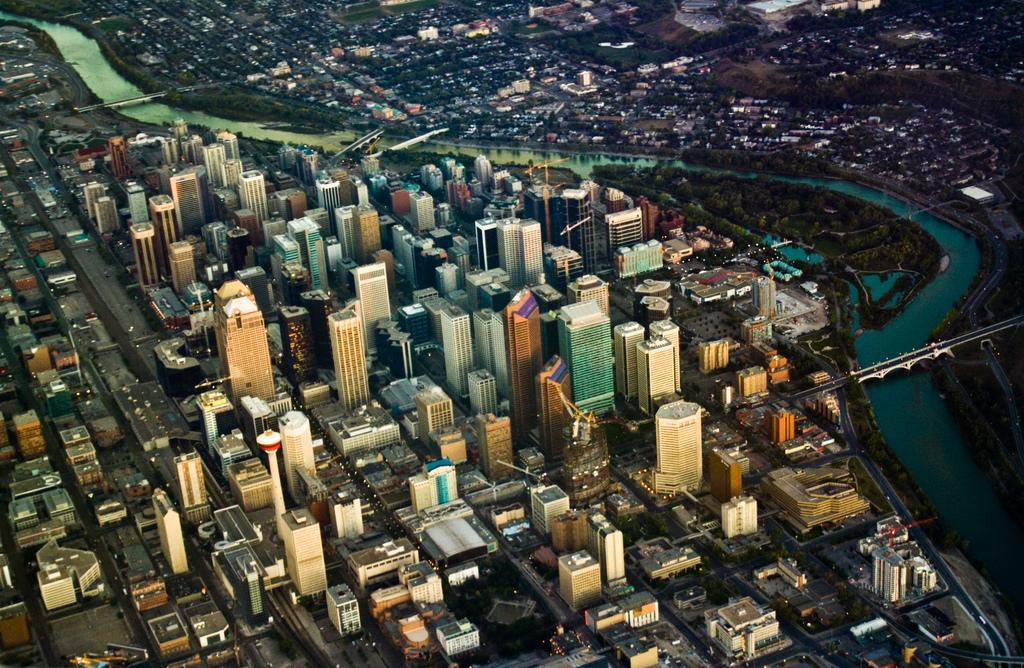What type of structures can be seen in the image? There are many buildings in the image. What else can be seen besides the buildings? There are poles, water, trees, and cranes visible in the image. Can you describe the water in the image? The water is visible in the image, but its specific location or characteristics are not mentioned. What type of objects are present in the image, but not specified? There are unspecified objects in the image. What type of garden can be seen in the image? There is no garden present in the image. What color is the sweater worn by the person in the image? There is no person or sweater present in the image. 